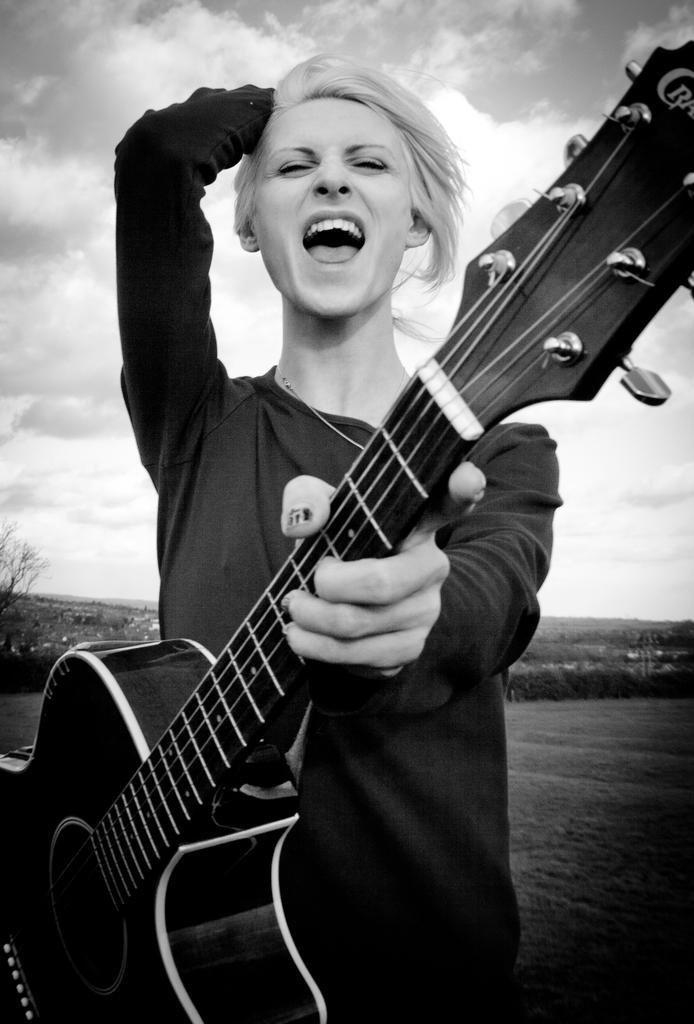Describe this image in one or two sentences. In this image I see a person who is holding a guitar and in the background I see the sky. 